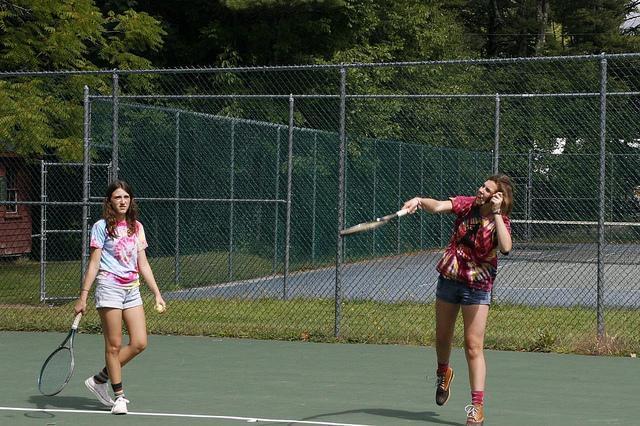How many people are there?
Give a very brief answer. 2. 